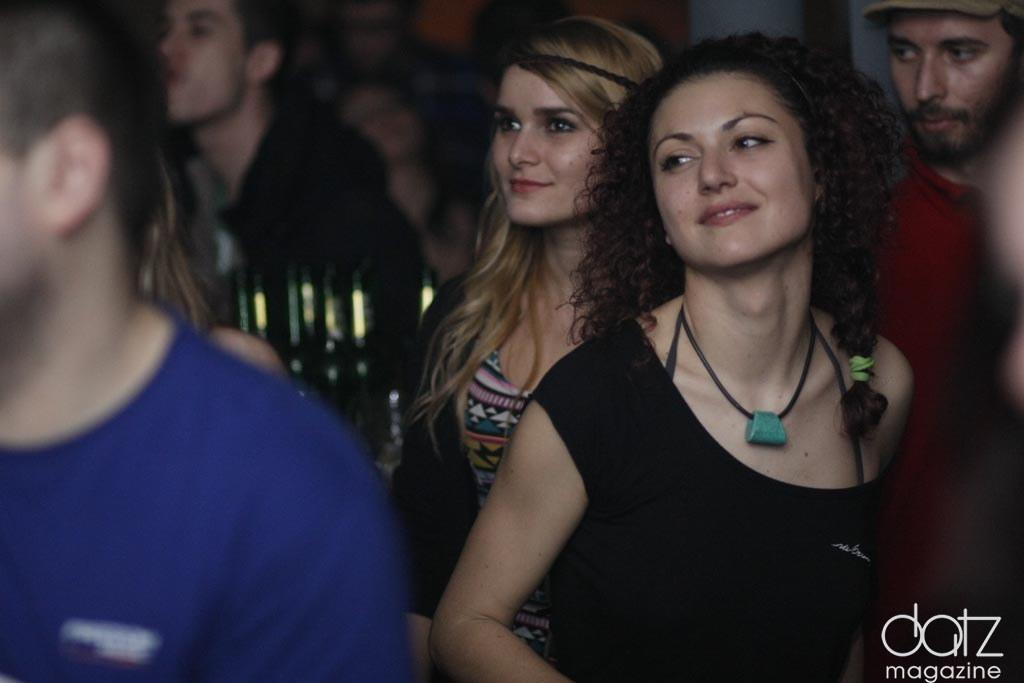How many people are visible in the image? There are many people in the image. Can you describe the man on the left side of the image? The man on the left side of the image is wearing a blue T-shirt. What can be said about the woman in the front of the image? The woman in the front of the image is wearing a black T-shirt. What is the general distribution of people in the image? There are many people in the background of the image as well. Can you tell me where the kitty is hiding in the image? There is no kitty present in the image. How many places can be seen in the image? The image does not depict specific places; it primarily focuses on people. 